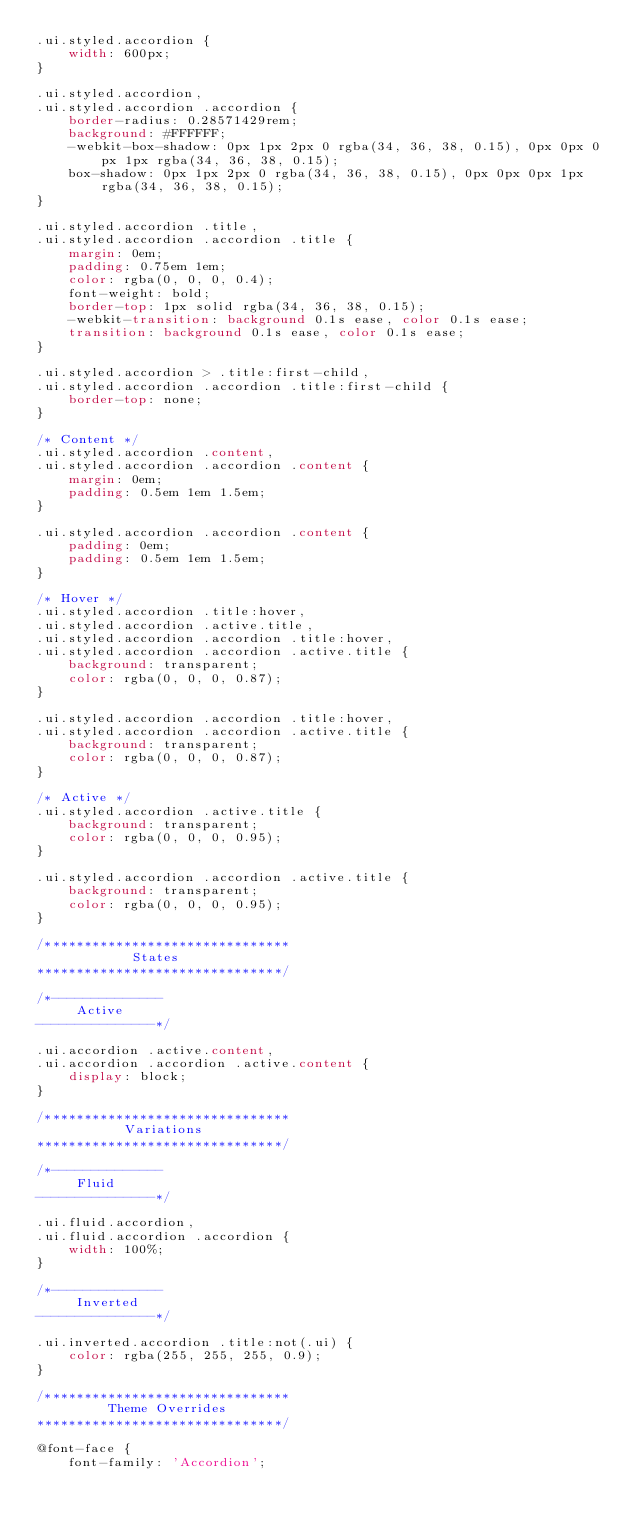Convert code to text. <code><loc_0><loc_0><loc_500><loc_500><_CSS_>.ui.styled.accordion {
    width: 600px;
}

.ui.styled.accordion,
.ui.styled.accordion .accordion {
    border-radius: 0.28571429rem;
    background: #FFFFFF;
    -webkit-box-shadow: 0px 1px 2px 0 rgba(34, 36, 38, 0.15), 0px 0px 0px 1px rgba(34, 36, 38, 0.15);
    box-shadow: 0px 1px 2px 0 rgba(34, 36, 38, 0.15), 0px 0px 0px 1px rgba(34, 36, 38, 0.15);
}

.ui.styled.accordion .title,
.ui.styled.accordion .accordion .title {
    margin: 0em;
    padding: 0.75em 1em;
    color: rgba(0, 0, 0, 0.4);
    font-weight: bold;
    border-top: 1px solid rgba(34, 36, 38, 0.15);
    -webkit-transition: background 0.1s ease, color 0.1s ease;
    transition: background 0.1s ease, color 0.1s ease;
}

.ui.styled.accordion > .title:first-child,
.ui.styled.accordion .accordion .title:first-child {
    border-top: none;
}

/* Content */
.ui.styled.accordion .content,
.ui.styled.accordion .accordion .content {
    margin: 0em;
    padding: 0.5em 1em 1.5em;
}

.ui.styled.accordion .accordion .content {
    padding: 0em;
    padding: 0.5em 1em 1.5em;
}

/* Hover */
.ui.styled.accordion .title:hover,
.ui.styled.accordion .active.title,
.ui.styled.accordion .accordion .title:hover,
.ui.styled.accordion .accordion .active.title {
    background: transparent;
    color: rgba(0, 0, 0, 0.87);
}

.ui.styled.accordion .accordion .title:hover,
.ui.styled.accordion .accordion .active.title {
    background: transparent;
    color: rgba(0, 0, 0, 0.87);
}

/* Active */
.ui.styled.accordion .active.title {
    background: transparent;
    color: rgba(0, 0, 0, 0.95);
}

.ui.styled.accordion .accordion .active.title {
    background: transparent;
    color: rgba(0, 0, 0, 0.95);
}

/*******************************
            States
*******************************/

/*--------------
     Active
---------------*/

.ui.accordion .active.content,
.ui.accordion .accordion .active.content {
    display: block;
}

/*******************************
           Variations
*******************************/

/*--------------
     Fluid
---------------*/

.ui.fluid.accordion,
.ui.fluid.accordion .accordion {
    width: 100%;
}

/*--------------
     Inverted
---------------*/

.ui.inverted.accordion .title:not(.ui) {
    color: rgba(255, 255, 255, 0.9);
}

/*******************************
         Theme Overrides
*******************************/

@font-face {
    font-family: 'Accordion';</code> 